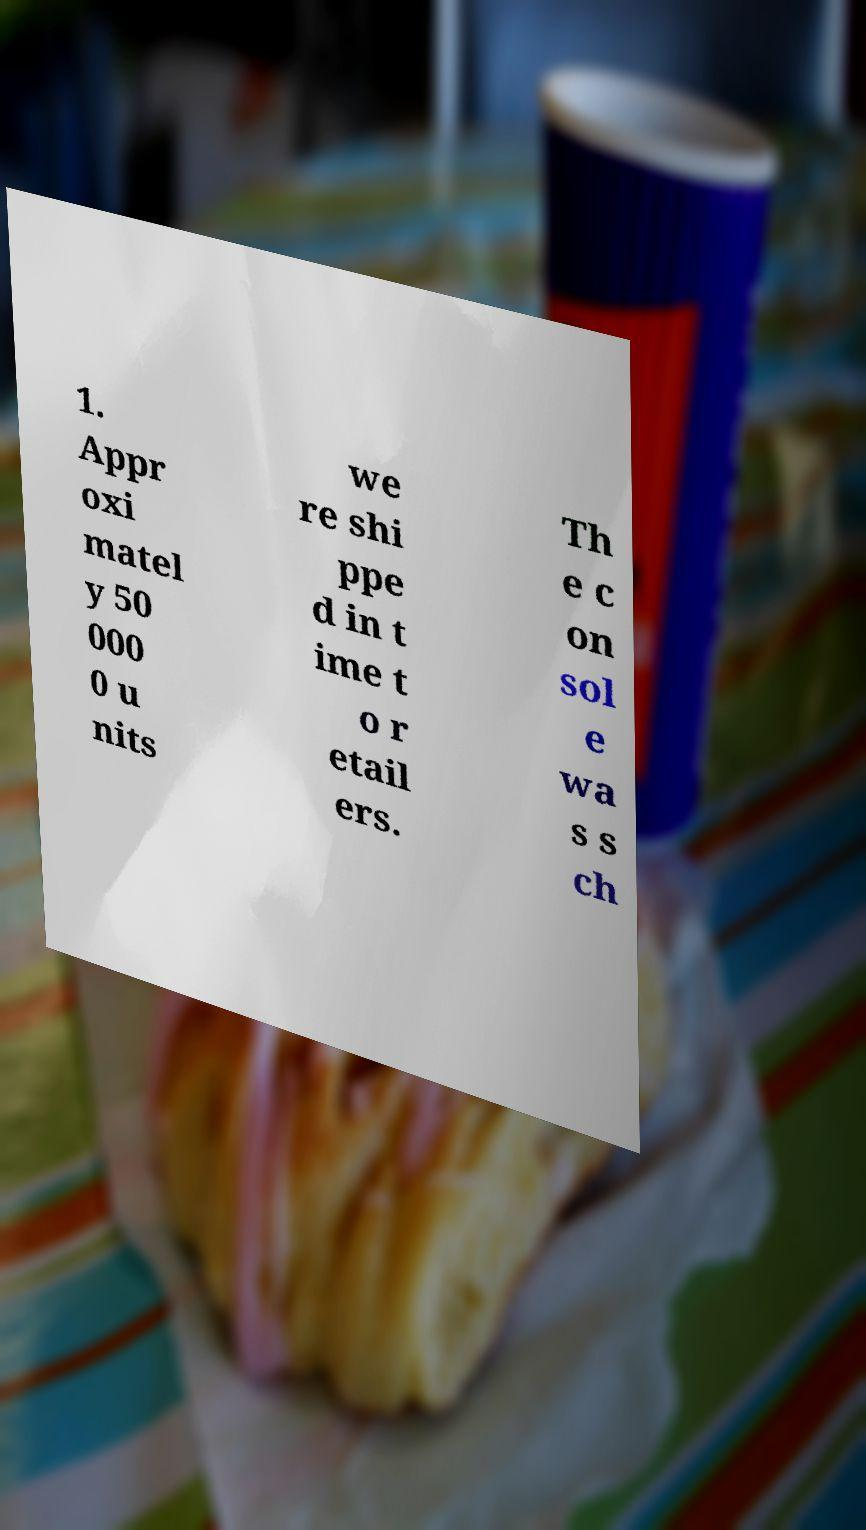There's text embedded in this image that I need extracted. Can you transcribe it verbatim? 1. Appr oxi matel y 50 000 0 u nits we re shi ppe d in t ime t o r etail ers. Th e c on sol e wa s s ch 